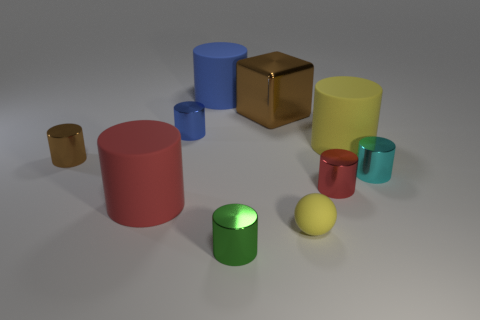Are there any large brown objects that have the same material as the ball?
Give a very brief answer. No. What size is the other object that is the same color as the large metal object?
Keep it short and to the point. Small. How many rubber things are both in front of the big blue rubber cylinder and behind the tiny matte sphere?
Your answer should be compact. 2. What is the material of the large cylinder that is behind the brown shiny block?
Offer a very short reply. Rubber. How many metallic cylinders are the same color as the metal cube?
Provide a succinct answer. 1. There is a cube that is the same material as the small green object; what is its size?
Your answer should be compact. Large. How many things are either big yellow things or small purple rubber cubes?
Your answer should be compact. 1. The large object behind the brown metallic block is what color?
Ensure brevity in your answer.  Blue. There is a yellow matte thing that is the same shape as the tiny cyan metallic object; what is its size?
Keep it short and to the point. Large. How many things are red metallic things that are behind the small ball or large cylinders that are behind the tiny cyan object?
Keep it short and to the point. 3. 